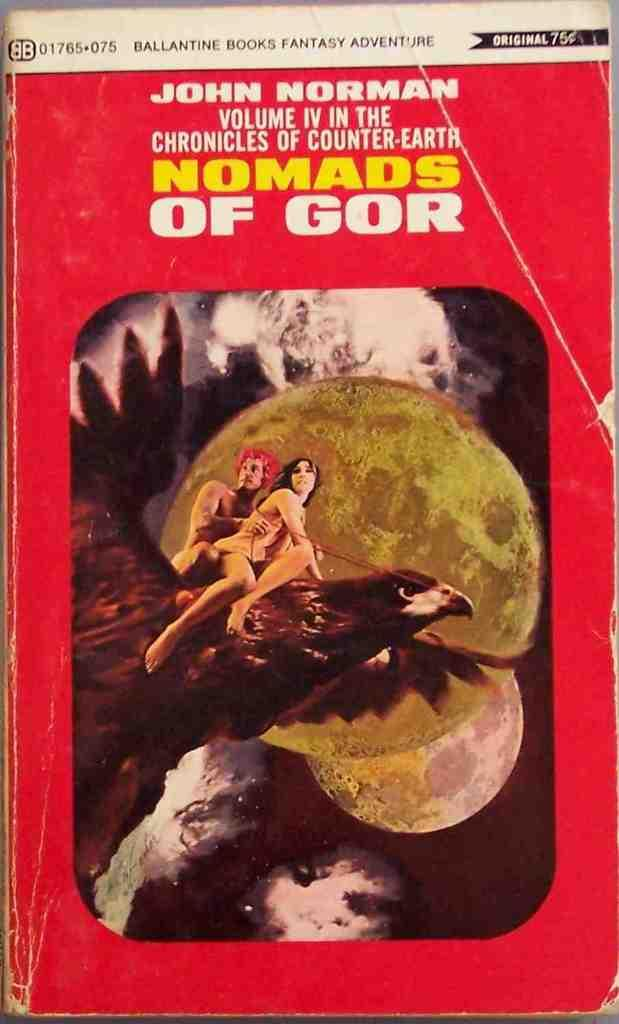<image>
Offer a succinct explanation of the picture presented. A book with a couple riding an eagle titled Nomads of Gor. 